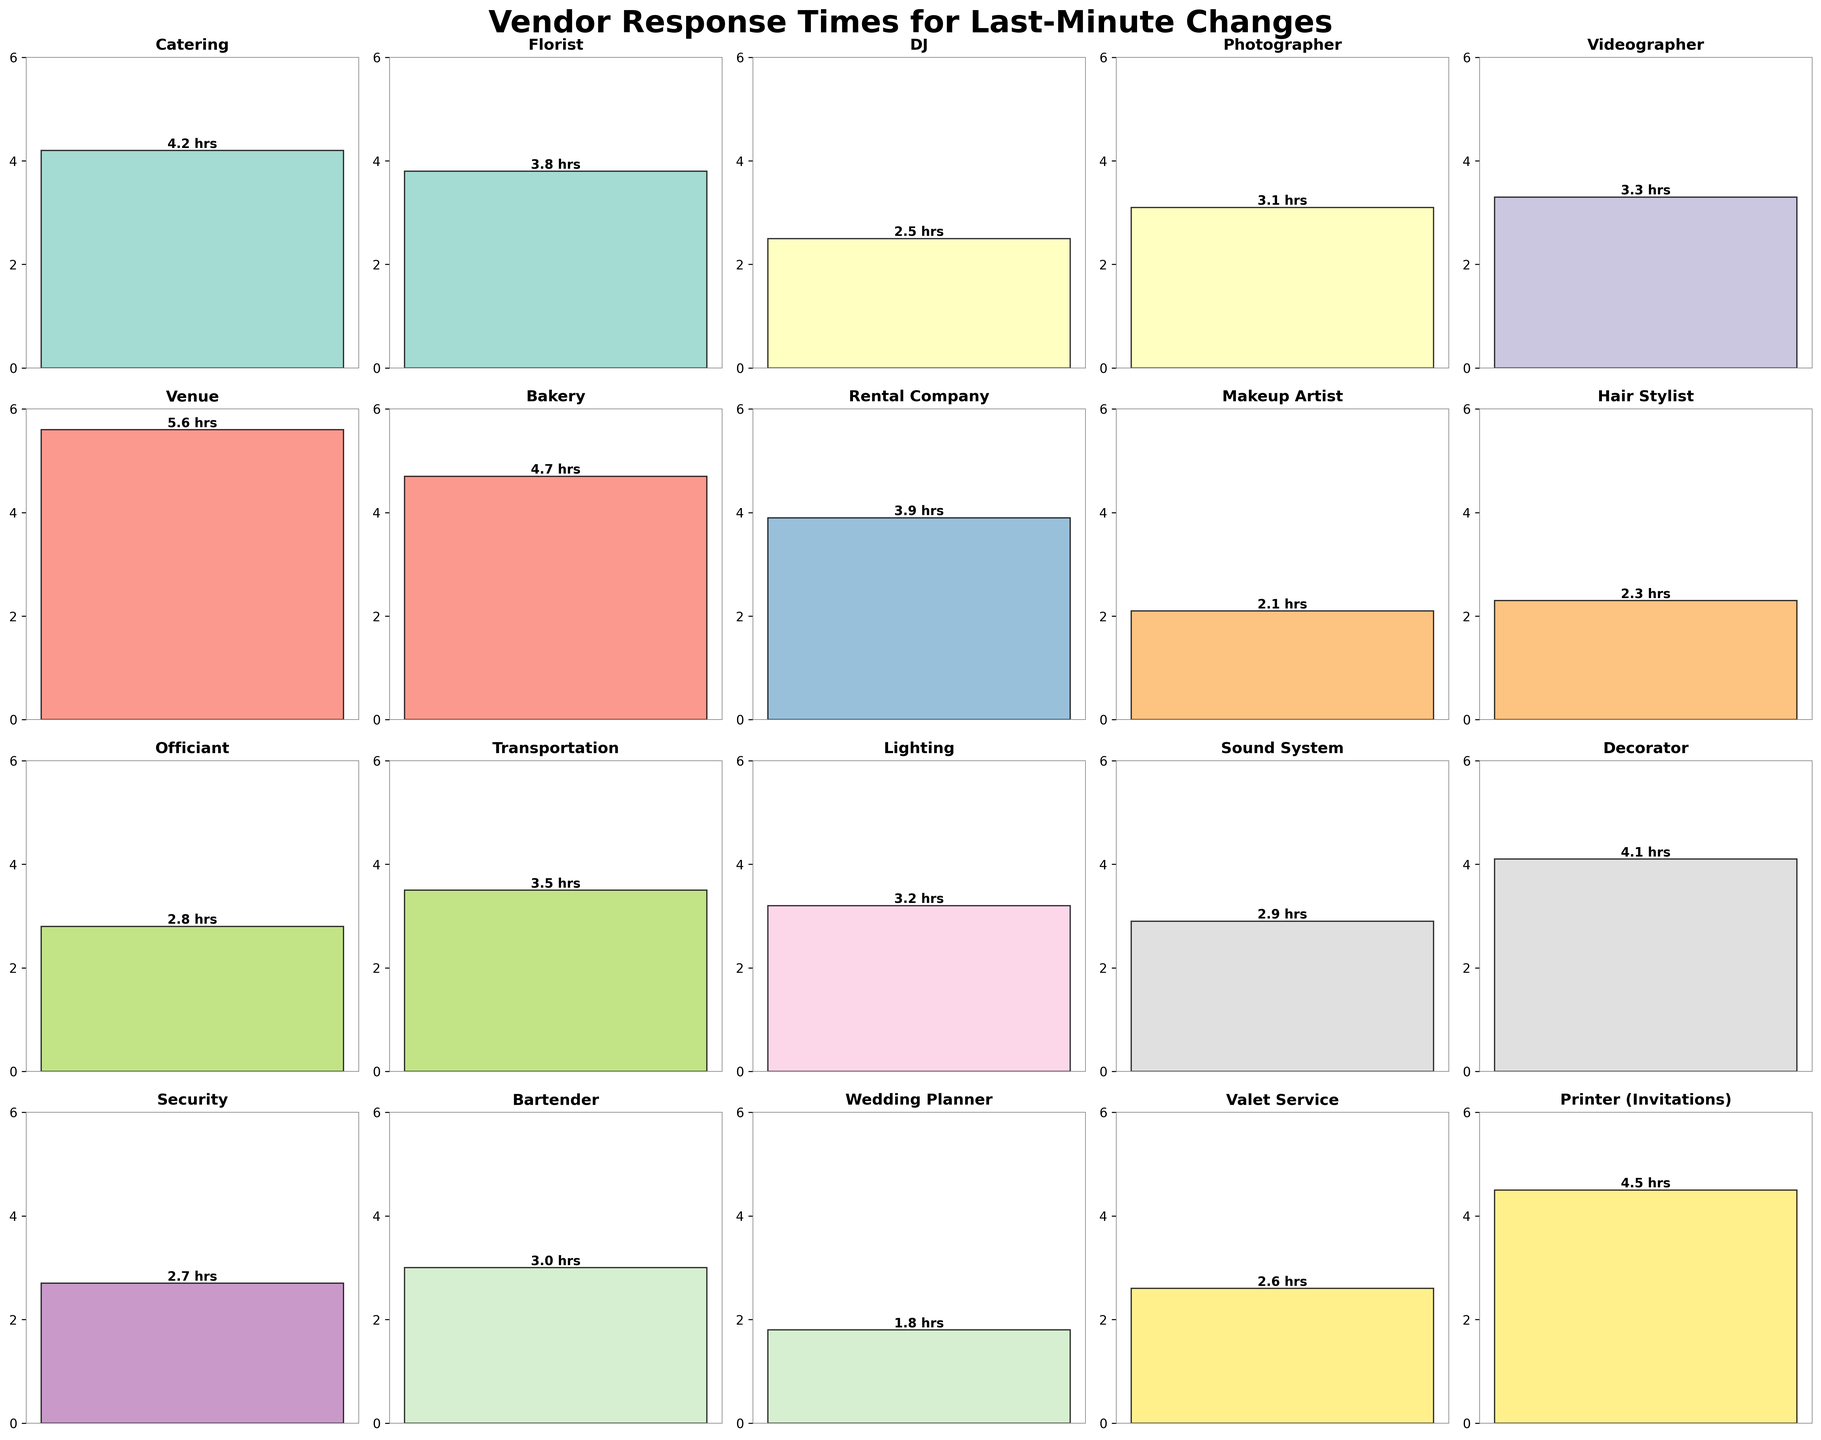Which service has the highest response time? By looking at the height of the bars on the subplots, the tallest bar indicates the highest response time. The venue has the tallest bar.
Answer: Venue Which service has the shortest response time? Observing the height of the bars, the shortest bar represents the lowest response time. The wedding planner has the shortest bar.
Answer: Wedding Planner What is the difference in response time between the Catering and Bakeries services? Locate the bars corresponding to Catering and Bakery. Catering has a response time of 4.2 hours, and Bakery has 4.7 hours. The difference is 4.7 - 4.2.
Answer: 0.5 hours Which services have response times lower than 3 hours? Scan through the bars and identify those that are below the 3-hour mark. These services are DJ (2.5), Makeup Artist (2.1), Hair Stylist (2.3), Officiant (2.8), Sound System (2.9), Security (2.7), Bartender (3.0), Wedding Planner (1.8), and Valet Service (2.6).
Answer: DJ, Makeup Artist, Hair Stylist, Officiant, Sound System, Security, Bartender, Wedding Planner, Valet Service What is the average response time of Florist, DJ, and Photographer? Identify the response times for Florist (3.8), DJ (2.5), and Photographer (3.1). Sum these values: 3.8 + 2.5 + 3.1 = 9.4. Divide the sum by 3 to find the average: 9.4 / 3.
Answer: 3.13 hours Which response time is closer to 4 hours, Bartender or Photographer? Compare the response times of Bartender (3.0) and Photographer (3.1) to 4 hours. The difference for Bartender is 4 - 3 = 1 and for Photographer is 4 - 3.1 = 0.9.
Answer: Photographer How many services have response times between 3 and 4 hours? Check each bar to see if it falls within the specified range. The services that satisfy this condition are Florist (3.8), Photographer (3.1), Videographer (3.3), Rental Company (3.9), Transportation (3.5), Lighting (3.2), Sound System (2.9), and Bartender (3.0).
Answer: 8 What is the total response time for the Makeup Artist, DJ, and Valet Service combined? Add the response times together: Makeup Artist (2.1), DJ (2.5), and Valet Service (2.6). The sum is 2.1 + 2.5 + 2.6.
Answer: 7.2 hours Which two services have response times that are closest to each other? Compare the response times visually to identify bars of nearly equal height. Florist (3.8) and Rental Company (3.9) are the closest.
Answer: Florist and Rental Company What's the median response time of all the services? List all response times in ascending order: 1.8, 2.1, 2.3, 2.5, 2.6, 2.7, 2.8, 2.9, 3.0, 3.1, 3.2, 3.3, 3.5, 3.8, 3.9, 4.1, 4.2, 4.5, 4.7, 5.6. With 20 values, the median is the average of the 10th and 11th values: (3.1 + 3.2) / 2.
Answer: 3.15 